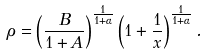<formula> <loc_0><loc_0><loc_500><loc_500>\rho = \left ( \frac { B } { 1 + A } \right ) ^ { \frac { 1 } { 1 + \alpha } } \left ( 1 + \frac { 1 } { x } \right ) ^ { \frac { 1 } { 1 + \alpha } } .</formula> 